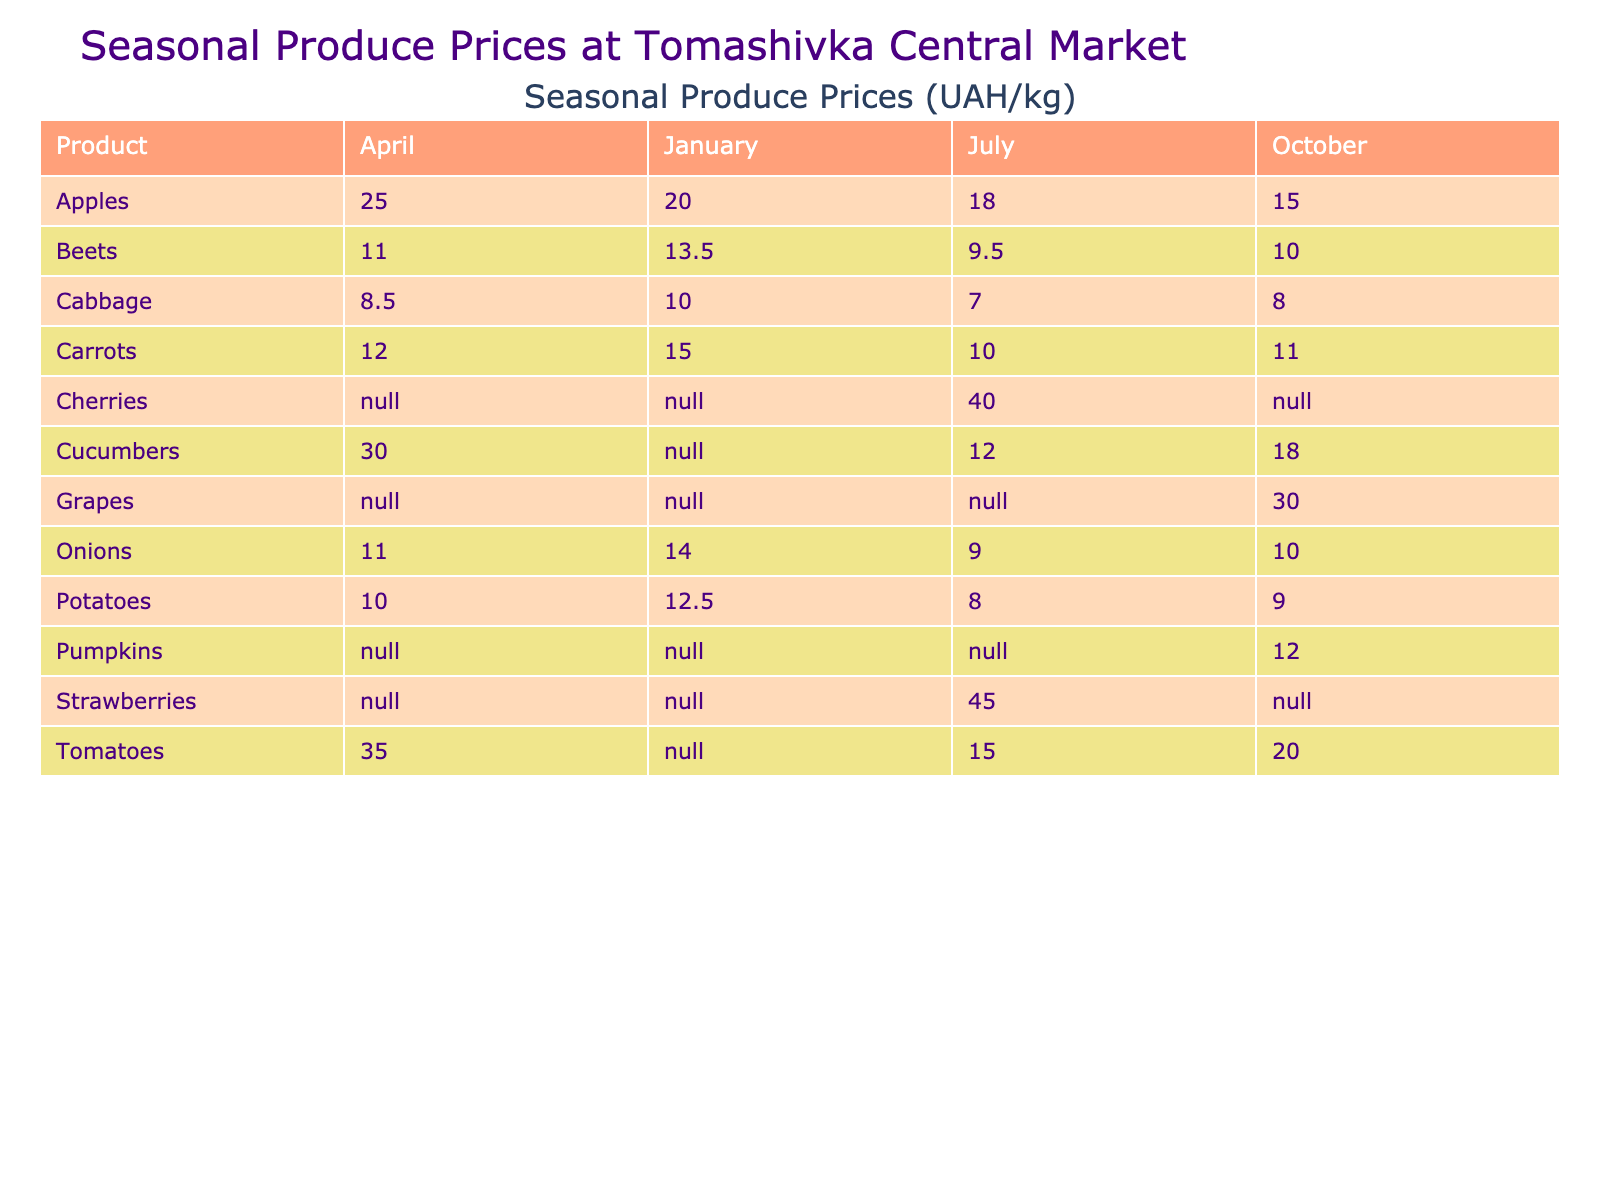What is the price of potatoes in October? The table shows that the price of potatoes in October is listed, which is 9.00 UAH/kg.
Answer: 9.00 Which product had the highest price in July? By looking at the table for July, the prices for products are as follows: potatoes (8.00), carrots (10.00), cabbage (7.00), onions (9.00), apples (18.00), beets (9.50), tomatoes (15.00), cucumbers (12.00), cherries (40.00), and strawberries (45.00). The highest price is for strawberries at 45.00 UAH/kg.
Answer: 45.00 Is cabbage available in January? The table indicates that cabbage is listed for January with a high availability. Therefore, the answer is yes.
Answer: Yes What is the average price of onions across all months? The prices for onions in different months are: January (14.00), April (11.00), July (9.00), and October (10.00). To find the average, we add these values: 14.00 + 11.00 + 9.00 + 10.00 = 44.00, and then divide by 4 (the number of months), giving us an average of 44.00 / 4 = 11.00.
Answer: 11.00 In which month are carrots least available? Looking through the table, carrots in January have medium availability, in April they have low availability, in July they have high availability, and in October they have high availability. Since April has low availability, it is the month when carrots are least available.
Answer: April Which product shows a price increase from April to July? Checking the table, we compare the prices from April and July: Potatoes (10.00 to 8.00), Carrots (12.00 to 10.00), Cabbage (8.50 to 7.00), Onions (11.00 to 9.00), Apples (25.00 to 18.00), Beets (11.00 to 9.50), Tomatoes (35.00 to 15.00), Cucumbers (30.00 to 12.00). The previous month's prices indicate a price increase for apples. Thus, only apples showed a price increase from April to July.
Answer: Apples How many products have medium availability in October? From the table, the products listed for October are potatoes (high), carrots (high), cabbage (high), onions (high), apples (high), beets (high), tomatoes (medium), cucumbers (medium), and pumpkins (high) - a total of 2 products (tomatoes and cucumbers) show medium availability in that month.
Answer: 2 Which month has the lowest prices for cabbage? In looking through the table, the prices for cabbage are: January (10.00), April (8.50), July (7.00), and October (8.00). The lowest price recorded is in July at 7.00 UAH/kg.
Answer: July 